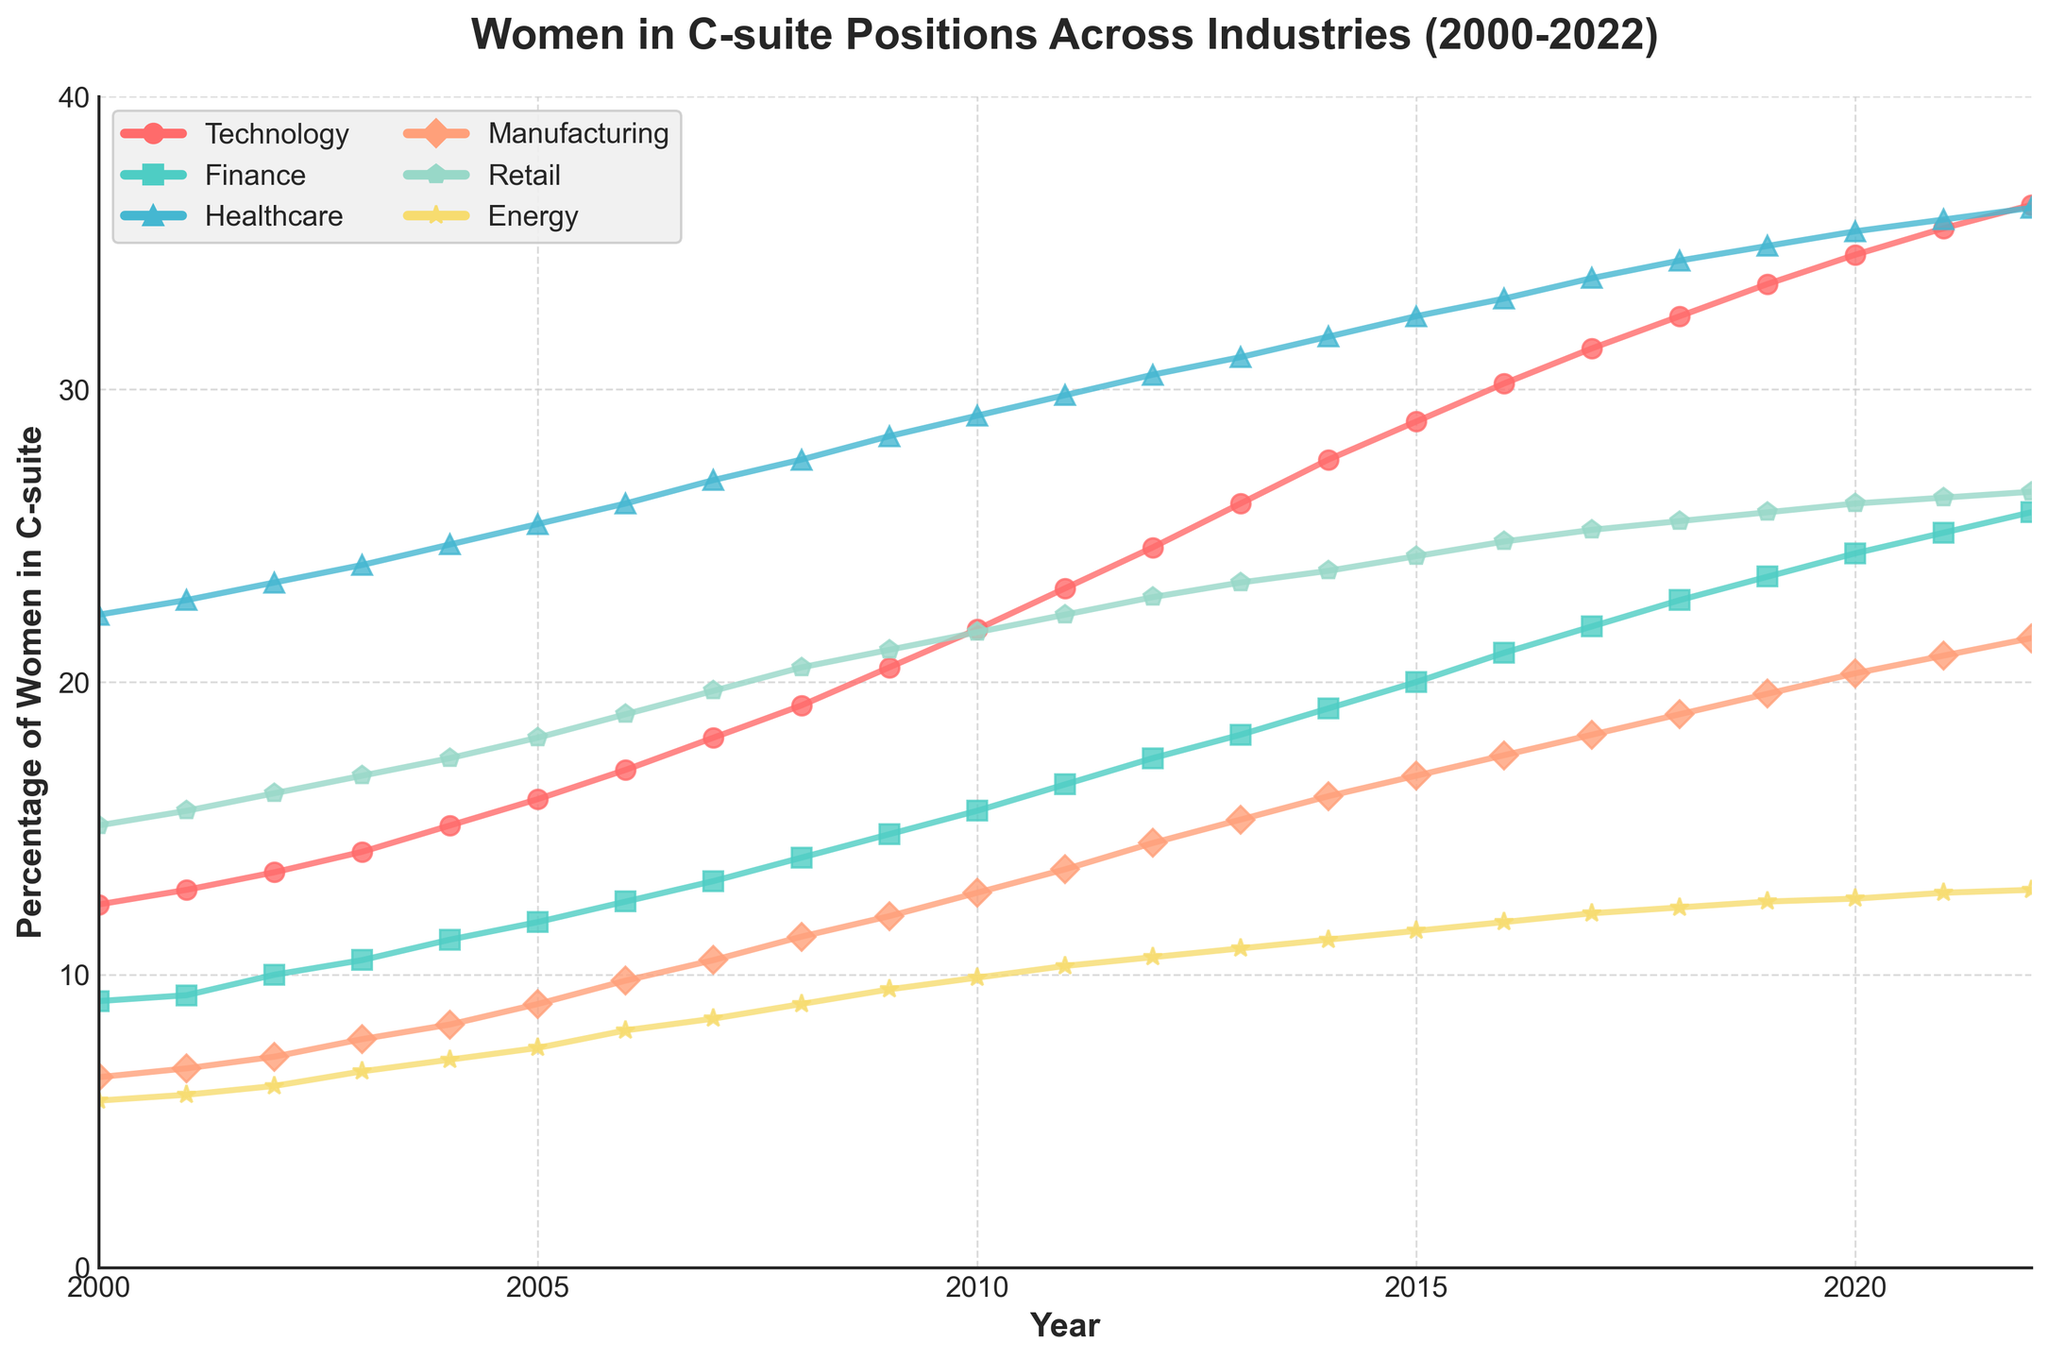What is the title of the figure? The title is typically placed at the top of the figure and is an essential element for understanding the overall subject of the plot. In this case, it is prominently displayed.
Answer: Women in C-suite Positions Across Industries (2000-2022) What year has the highest percentage of women in C-suite positions in the Technology industry? To find the highest percentage, we observe the trendline for Technology on the plot and identify the peak year.
Answer: 2022 Which industry had the lowest percentage of women in C-suite positions in 2000? We locate the year 2000 on the x-axis and compare the percentages of each industry at that point. The industry with the lowest value is the answer.
Answer: Energy How did the percentage of women in C-suite positions change for the Healthcare industry from 2000 to 2022? We look at the starting value for Healthcare in 2000 and the ending value in 2022 and calculate the difference.
Answer: Increased by 13.9% Which two industries have the most similar percentage of women in C-suite positions in 2022? By closely observing the values on the y-axis for all industries in 2022, we identify the two industries with the closest values.
Answer: Manufacturing and Retail How much did the percentage of women in C-suite positions in the Finance industry increase from 2010 to 2020? We find the Finance industry values for 2010 and 2020 and subtract the former from the latter to get the difference.
Answer: Increased by 8.8% In which year did the Energy industry surpass a 10% representation of women in C-suite positions for the first time? By following the trendline for the Energy industry, we locate the year when it crosses the 10% mark on the y-axis.
Answer: 2011 On average, how much did the percentage of women in C-suite positions in the Retail industry increase per year between 2000 and 2022? To find the average yearly increase, subtract the 2000 value from the 2022 value and then divide by the number of years (2022-2000).
Answer: Approximately 0.52% per year Which industry showed the most significant overall increase in the percentage of women in C-suite positions from 2000 to 2022? By calculating the total increase for each industry from 2000 to 2022 and comparing them, the one with the highest increase is identified.
Answer: Technology Did any industry show a decrease at any point in the percentage of women in C-suite positions from 2000 to 2022? We examine each trendline for any downward slopes within the given time frame.
Answer: No 